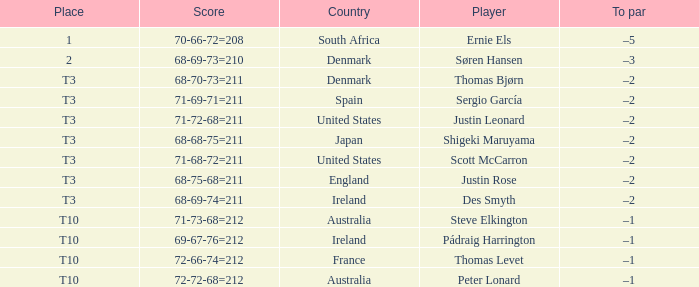What was the score for Peter Lonard? 72-72-68=212. 